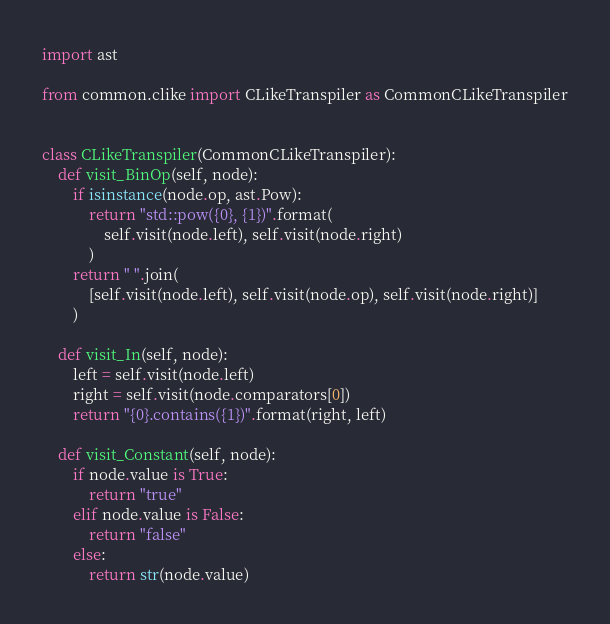Convert code to text. <code><loc_0><loc_0><loc_500><loc_500><_Python_>import ast

from common.clike import CLikeTranspiler as CommonCLikeTranspiler


class CLikeTranspiler(CommonCLikeTranspiler):
    def visit_BinOp(self, node):
        if isinstance(node.op, ast.Pow):
            return "std::pow({0}, {1})".format(
                self.visit(node.left), self.visit(node.right)
            )
        return " ".join(
            [self.visit(node.left), self.visit(node.op), self.visit(node.right)]
        )

    def visit_In(self, node):
        left = self.visit(node.left)
        right = self.visit(node.comparators[0])
        return "{0}.contains({1})".format(right, left)

    def visit_Constant(self, node):
        if node.value is True:
            return "true"
        elif node.value is False:
            return "false"
        else:
            return str(node.value)
</code> 